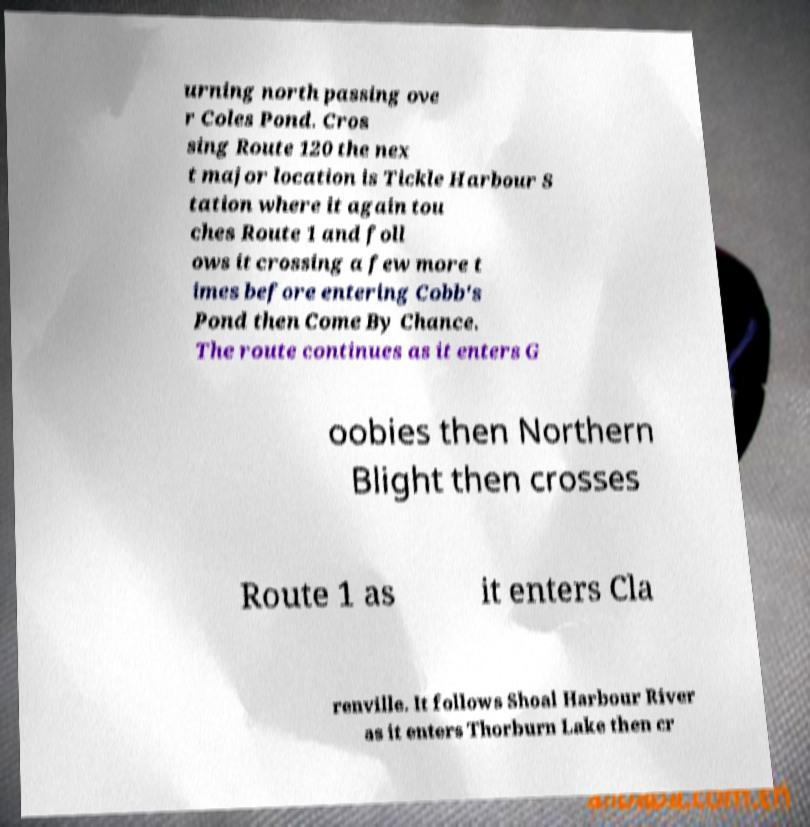Could you assist in decoding the text presented in this image and type it out clearly? urning north passing ove r Coles Pond. Cros sing Route 120 the nex t major location is Tickle Harbour S tation where it again tou ches Route 1 and foll ows it crossing a few more t imes before entering Cobb's Pond then Come By Chance. The route continues as it enters G oobies then Northern Blight then crosses Route 1 as it enters Cla renville. It follows Shoal Harbour River as it enters Thorburn Lake then cr 